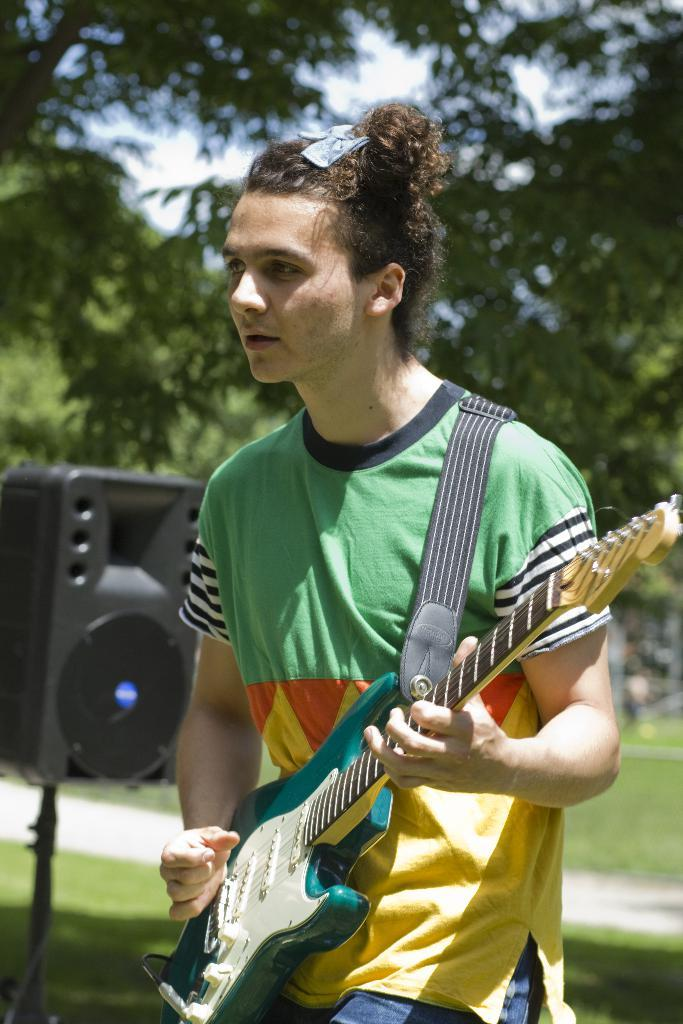What is the man in the image doing? The man is playing a guitar in the image. What type of surface is the man standing on? There is grass in the image, so the man is likely standing on grass. What can be seen in the background of the image? There are trees and the sky visible in the background of the image. What type of zebra can be seen in the image? There is no zebra present in the image. How many crows are perched on the guitar in the image? There are no crows present in the image, and the guitar is being played by the man. 